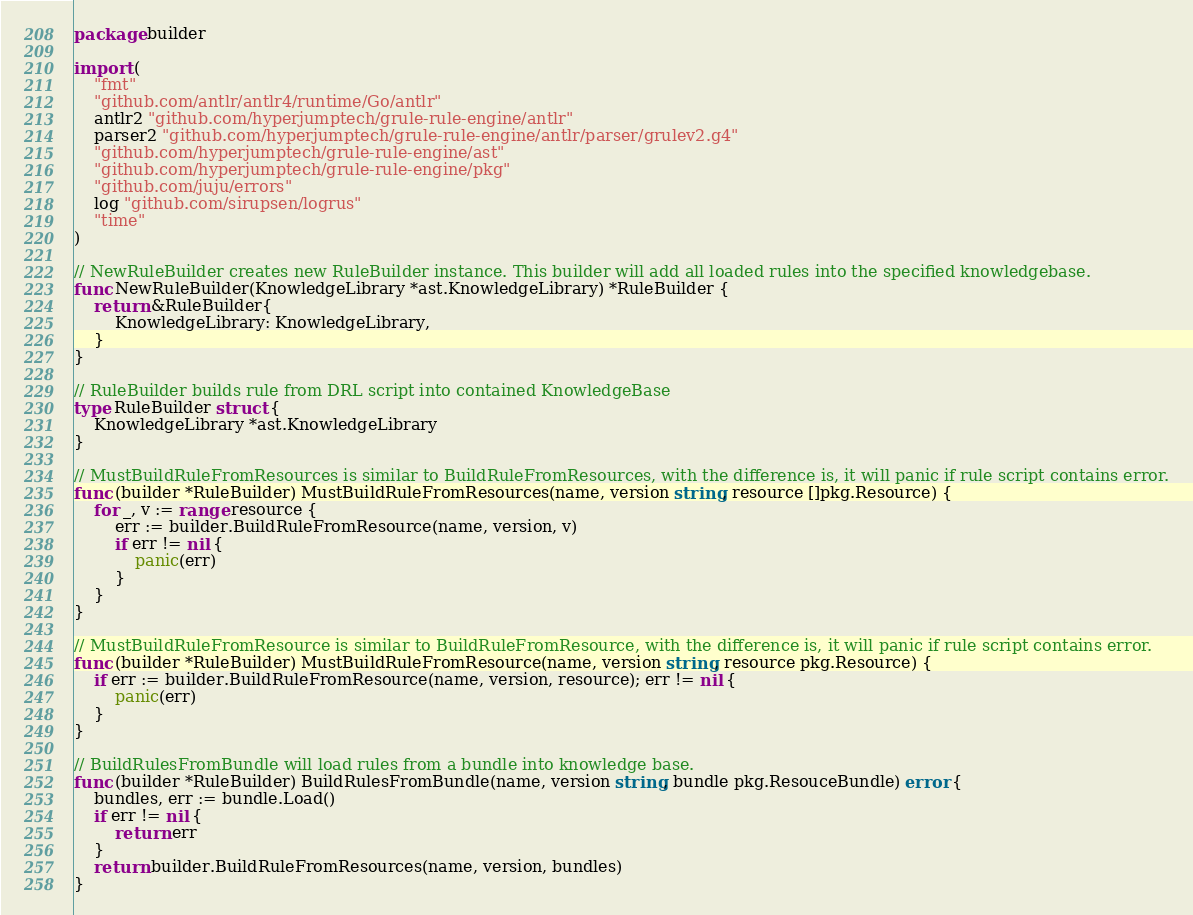<code> <loc_0><loc_0><loc_500><loc_500><_Go_>package builder

import (
	"fmt"
	"github.com/antlr/antlr4/runtime/Go/antlr"
	antlr2 "github.com/hyperjumptech/grule-rule-engine/antlr"
	parser2 "github.com/hyperjumptech/grule-rule-engine/antlr/parser/grulev2.g4"
	"github.com/hyperjumptech/grule-rule-engine/ast"
	"github.com/hyperjumptech/grule-rule-engine/pkg"
	"github.com/juju/errors"
	log "github.com/sirupsen/logrus"
	"time"
)

// NewRuleBuilder creates new RuleBuilder instance. This builder will add all loaded rules into the specified knowledgebase.
func NewRuleBuilder(KnowledgeLibrary *ast.KnowledgeLibrary) *RuleBuilder {
	return &RuleBuilder{
		KnowledgeLibrary: KnowledgeLibrary,
	}
}

// RuleBuilder builds rule from DRL script into contained KnowledgeBase
type RuleBuilder struct {
	KnowledgeLibrary *ast.KnowledgeLibrary
}

// MustBuildRuleFromResources is similar to BuildRuleFromResources, with the difference is, it will panic if rule script contains error.
func (builder *RuleBuilder) MustBuildRuleFromResources(name, version string, resource []pkg.Resource) {
	for _, v := range resource {
		err := builder.BuildRuleFromResource(name, version, v)
		if err != nil {
			panic(err)
		}
	}
}

// MustBuildRuleFromResource is similar to BuildRuleFromResource, with the difference is, it will panic if rule script contains error.
func (builder *RuleBuilder) MustBuildRuleFromResource(name, version string, resource pkg.Resource) {
	if err := builder.BuildRuleFromResource(name, version, resource); err != nil {
		panic(err)
	}
}

// BuildRulesFromBundle will load rules from a bundle into knowledge base.
func (builder *RuleBuilder) BuildRulesFromBundle(name, version string, bundle pkg.ResouceBundle) error {
	bundles, err := bundle.Load()
	if err != nil {
		return err
	}
	return builder.BuildRuleFromResources(name, version, bundles)
}
</code> 